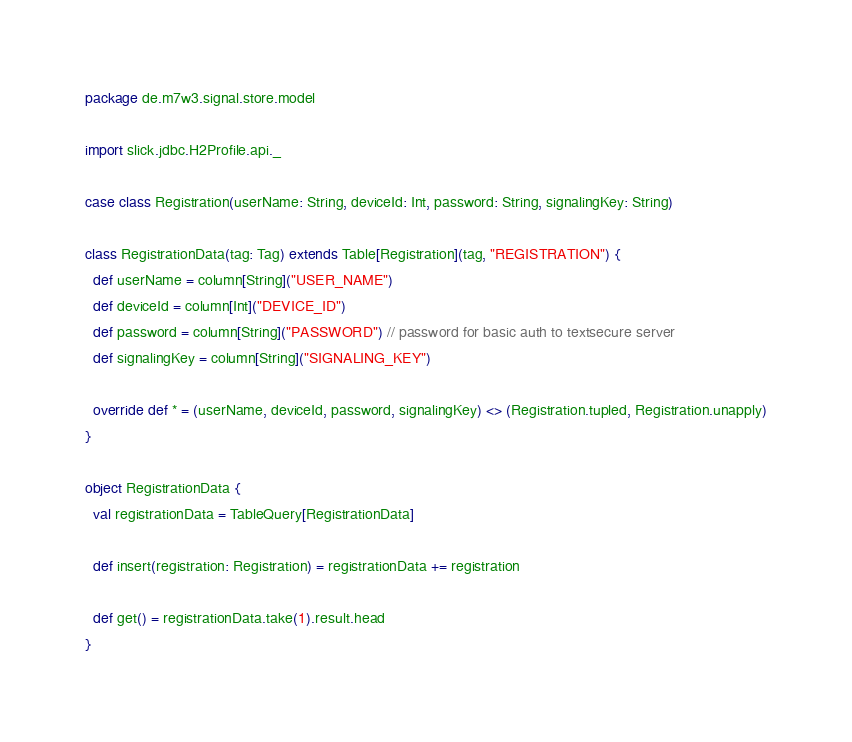<code> <loc_0><loc_0><loc_500><loc_500><_Scala_>package de.m7w3.signal.store.model

import slick.jdbc.H2Profile.api._

case class Registration(userName: String, deviceId: Int, password: String, signalingKey: String)

class RegistrationData(tag: Tag) extends Table[Registration](tag, "REGISTRATION") {
  def userName = column[String]("USER_NAME")
  def deviceId = column[Int]("DEVICE_ID")
  def password = column[String]("PASSWORD") // password for basic auth to textsecure server
  def signalingKey = column[String]("SIGNALING_KEY")

  override def * = (userName, deviceId, password, signalingKey) <> (Registration.tupled, Registration.unapply)
}

object RegistrationData {
  val registrationData = TableQuery[RegistrationData]

  def insert(registration: Registration) = registrationData += registration

  def get() = registrationData.take(1).result.head
}


</code> 